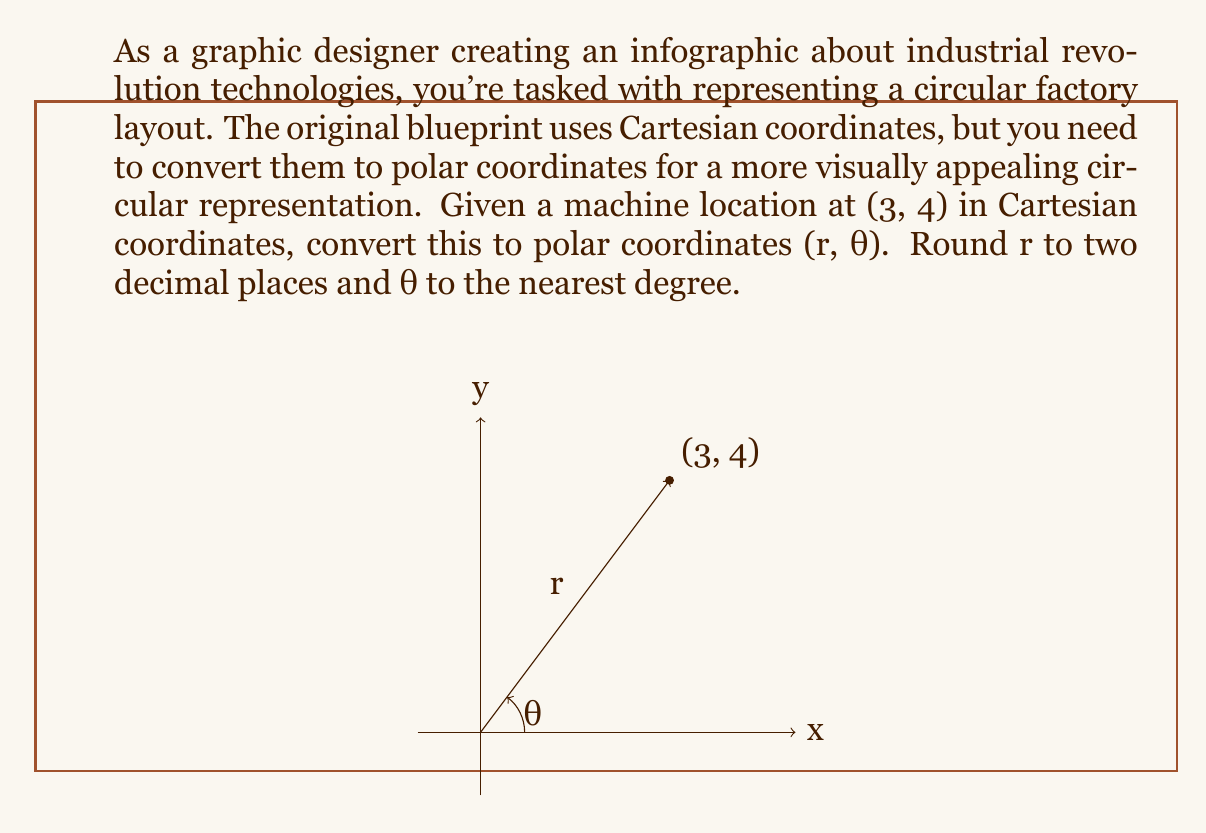Teach me how to tackle this problem. To convert Cartesian coordinates (x, y) to polar coordinates (r, θ), we use the following formulas:

1. For r (distance from origin):
   $$r = \sqrt{x^2 + y^2}$$

2. For θ (angle from positive x-axis):
   $$\theta = \tan^{-1}\left(\frac{y}{x}\right)$$

Step 1: Calculate r
$$r = \sqrt{3^2 + 4^2} = \sqrt{9 + 16} = \sqrt{25} = 5$$

Step 2: Calculate θ
$$\theta = \tan^{-1}\left(\frac{4}{3}\right) \approx 0.9273 \text{ radians}$$

Step 3: Convert θ to degrees
$$\theta \text{ in degrees} = 0.9273 \times \frac{180°}{\pi} \approx 53.13°$$

Step 4: Round r to two decimal places and θ to the nearest degree
r ≈ 5.00
θ ≈ 53°

Therefore, the polar coordinates are (5.00, 53°).
Answer: (5.00, 53°) 